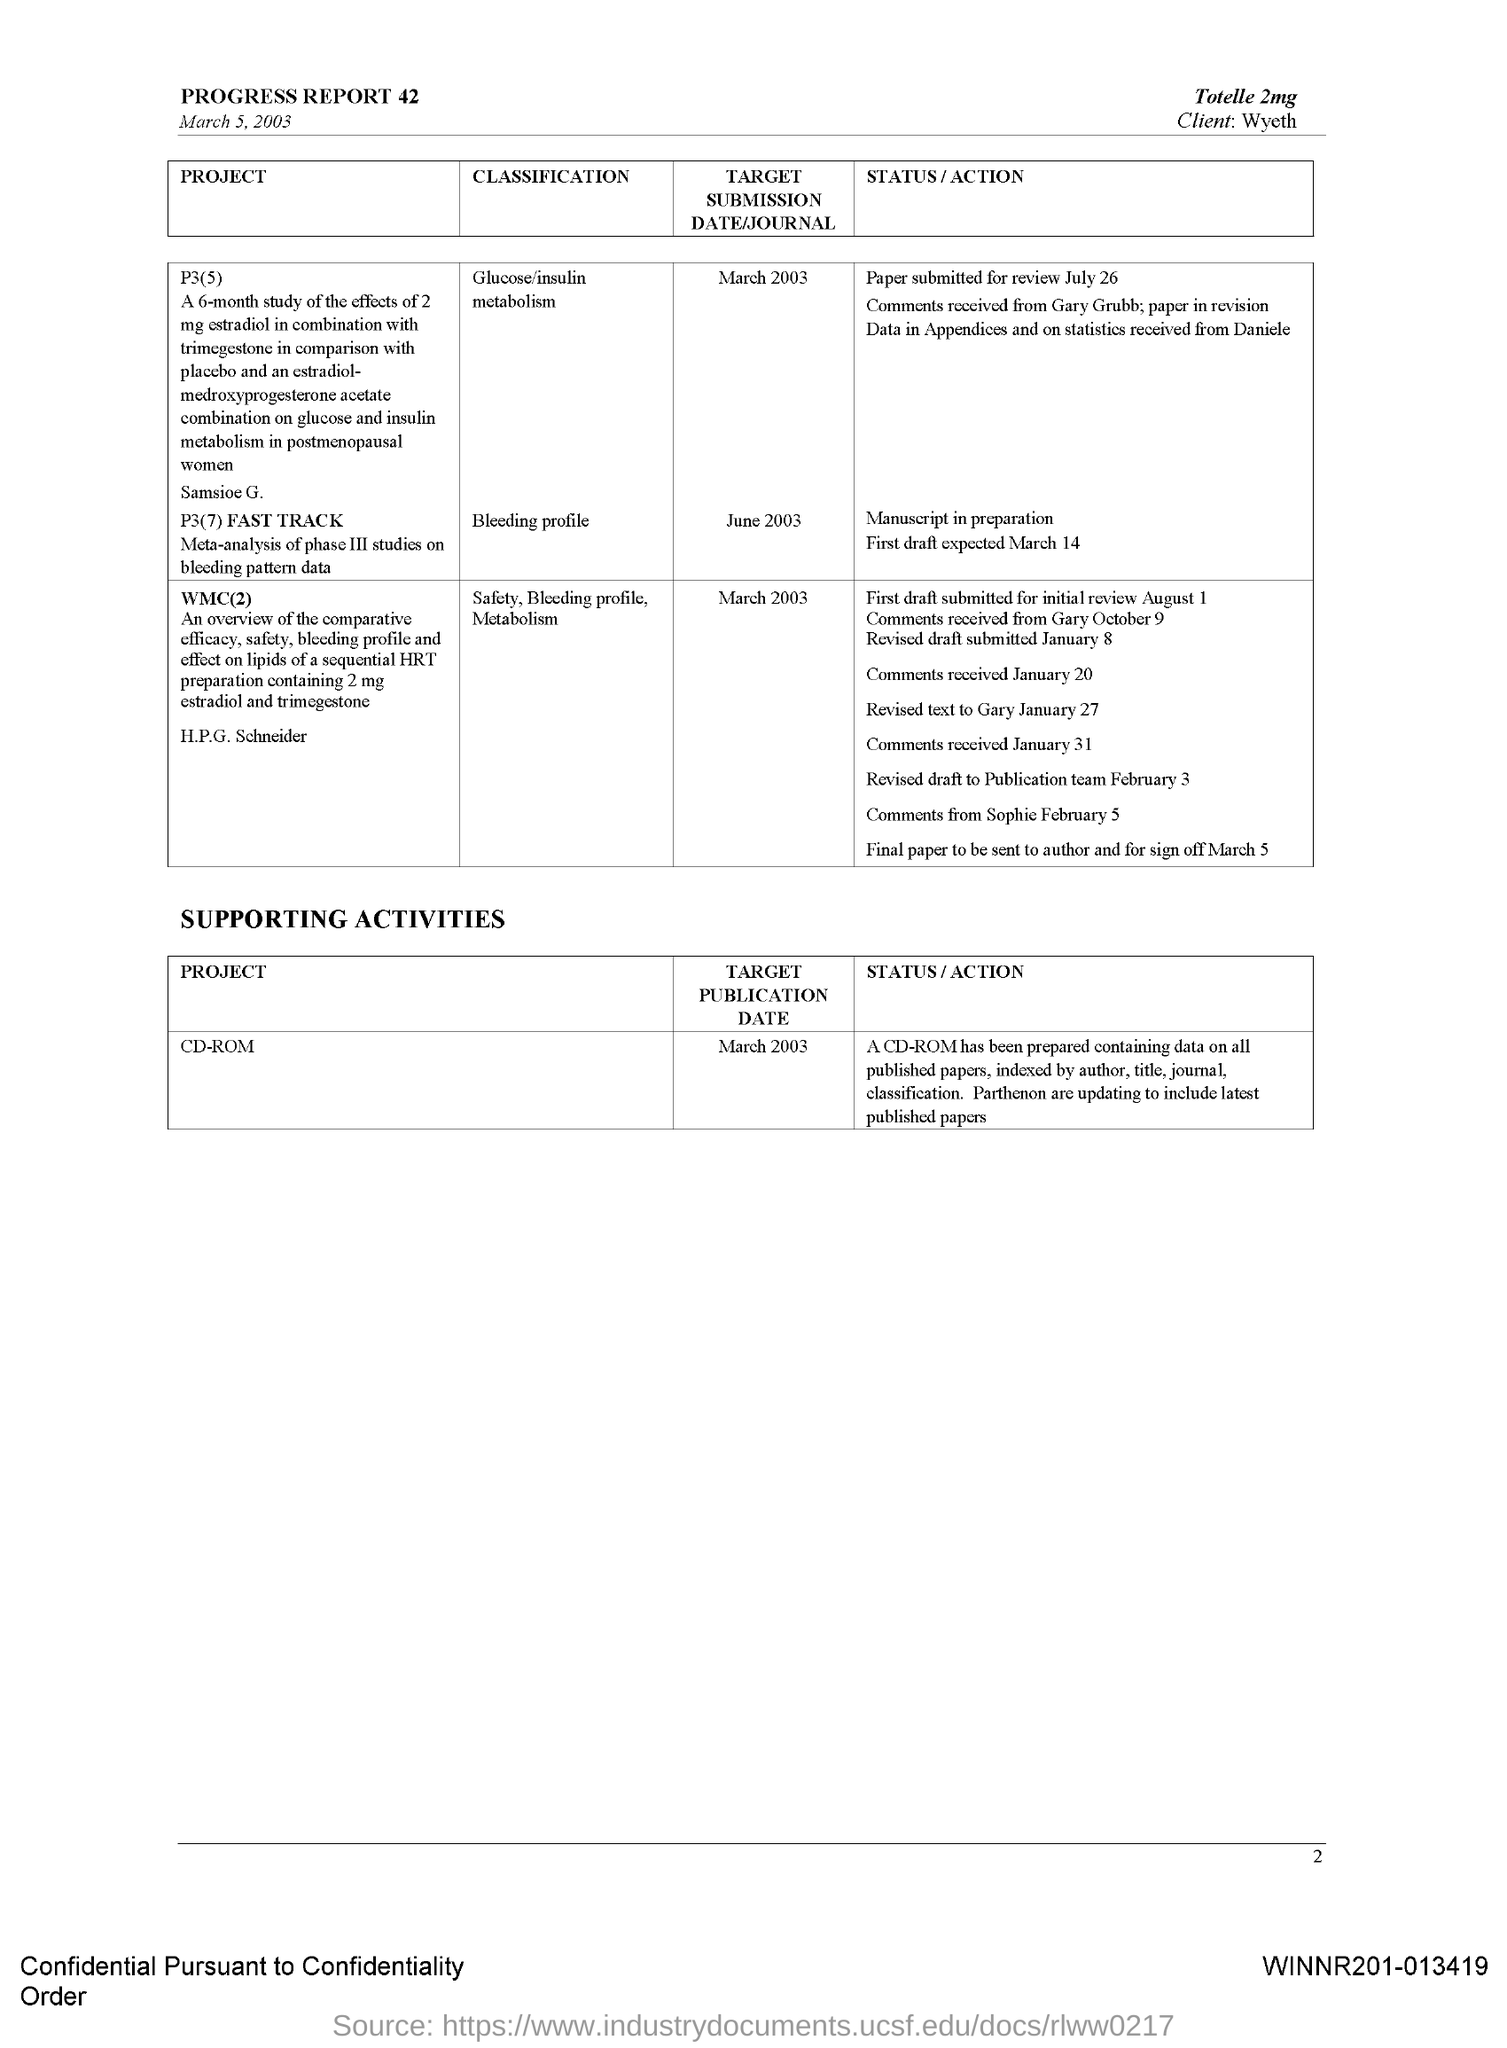What is the Target Publication Date/Journal for Classification "Glucose/insulin metabolism"?
Your answer should be very brief. March 2003. What is the Target Publication Date/Journal for Classification "Bleeding profile"?
Provide a succinct answer. June 2003. What is the Target Publication Date/Journal for Classification "Safety, Bleeding profile, metabolism"?
Your answer should be compact. March 2003. What is the Target Publication Date/Journal for Project "CD-ROM"?
Offer a terse response. March 2003. Who is the client?
Offer a very short reply. Wyeth. What is the date on the document?
Give a very brief answer. March 5, 2003. 